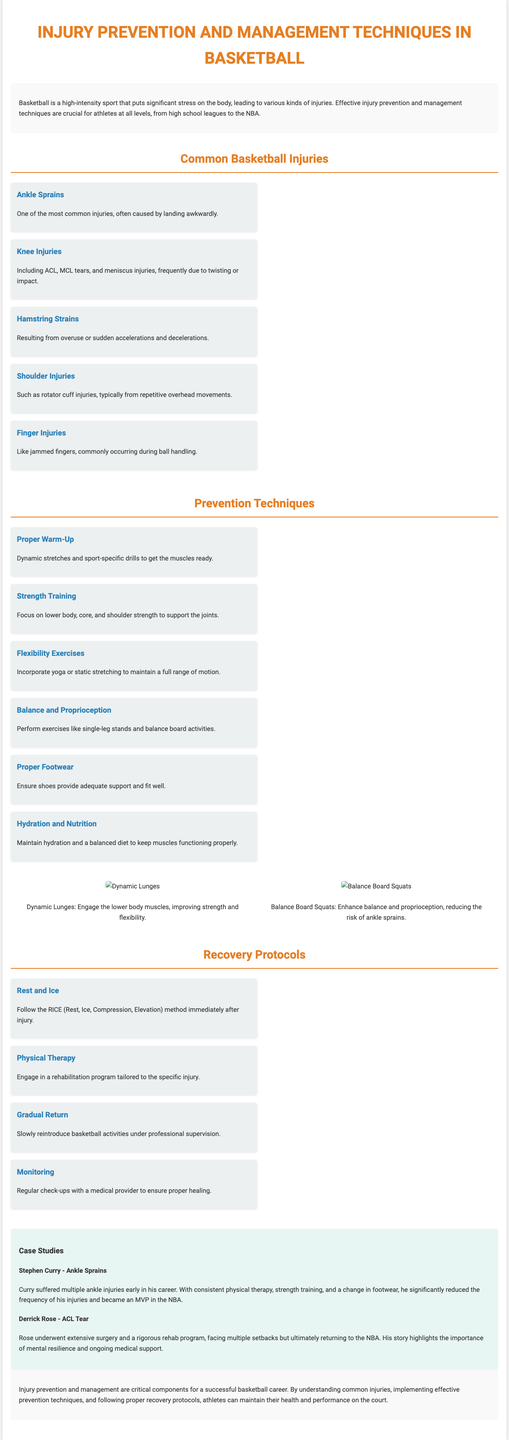What is one of the most common basketball injuries? The infographic lists "Ankle Sprains" as one of the most common injuries.
Answer: Ankle Sprains What does RICE stand for in recovery protocols? The recovery section mentions the acronym RICE, which stands for Rest, Ice, Compression, Elevation.
Answer: Rest, Ice, Compression, Elevation Who is a player mentioned that suffered from ACL tears? Derrick Rose is specifically mentioned as having undergone surgery for an ACL tear.
Answer: Derrick Rose What prevention technique focuses on lower body strength? "Strength Training" is highlighted as a prevention technique focusing on lower body strength.
Answer: Strength Training Which exercise is illustrated for enhancing balance and proprioception? The infographic features "Balance Board Squats" as an exercise to enhance balance and proprioception.
Answer: Balance Board Squats How many common basketball injuries are listed in the document? The infographic outlines five common basketball injuries.
Answer: Five What recovery step includes regular check-ups with a medical provider? "Monitoring" is the recovery step that involves regular check-ups to ensure proper healing.
Answer: Monitoring What color is predominantly used for headings in the document? The color orange (#e67e22) is consistently used for headings throughout the infographic.
Answer: Orange Which player is highlighted for managing ankle sprains effectively? Stephen Curry is discussed in terms of his successful management of ankle sprains.
Answer: Stephen Curry 